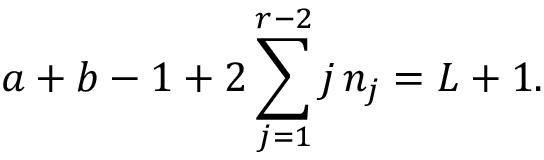<formula> <loc_0><loc_0><loc_500><loc_500>a + b - 1 + 2 \sum _ { j = 1 } ^ { r - 2 } j \, n _ { j } = L + 1 .</formula> 